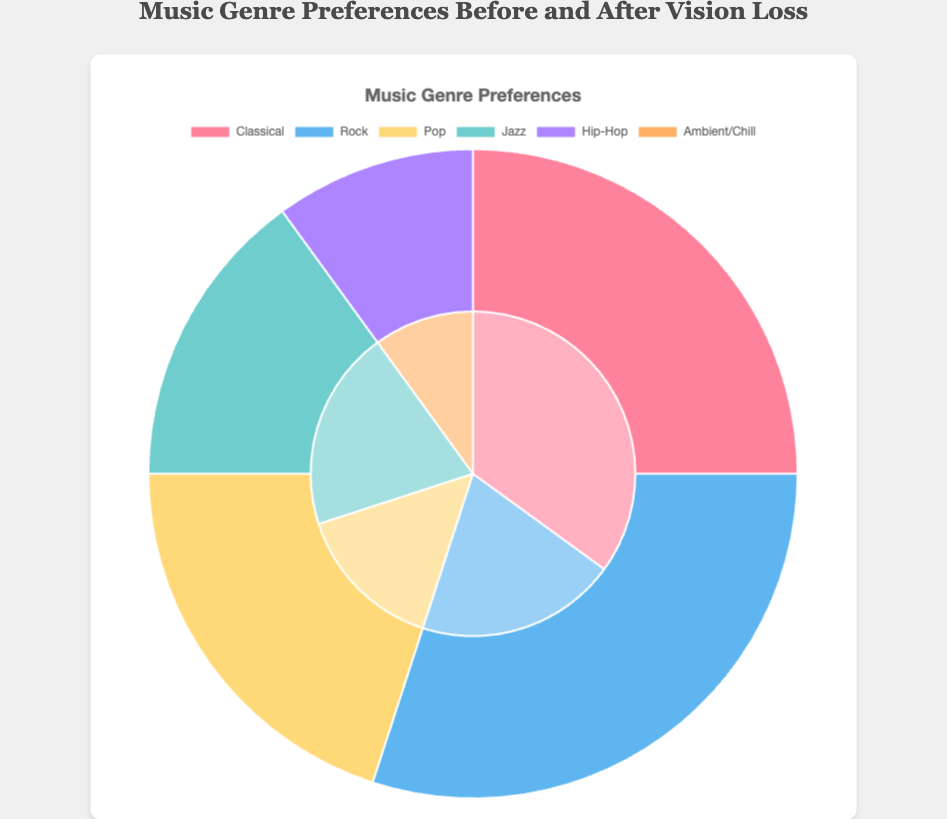Which genre saw the biggest increase after vision loss? Compare the percentages of each genre before and after vision loss. Classical music increased from 25% to 35%, which is the largest increase.
Answer: Classical What is the total percentage of Pop and Jazz after vision loss? Sum the percentages of Pop and Jazz after vision loss: 15% (Pop) + 20% (Jazz) = 35%.
Answer: 35% Which genre was present before vision loss but not after? Identify the genre listed before vision loss but missing after: Hip-Hop was present before (10%) and is not listed after.
Answer: Hip-Hop What are the two genres with the same percentage after vision loss? Identify genres with identical percentages after vision loss. Both Jazz and Classical have 20%.
Answer: Jazz and Rock How has the preference for Rock music changed after vision loss? Compare the percentage of Rock before (30%) and after vision loss (20%). The difference is 30% - 20% = 10%.
Answer: Decreased by 10% Which genre was added to the preferences after vision loss? Identify the genre present after vision loss but not before: Ambient/Chill makes its first appearance with 10%.
Answer: Ambient/Chill What is the combined percentage of Classical and Pop music before vision loss? Sum the percentages of Classical and Pop before vision loss: 25% (Classical) + 20% (Pop) = 45%.
Answer: 45% Which genre decreased and by what amount after vision loss? Rock music went from 30% to 20%, a decrease of 30% - 20% = 10%.
Answer: Rock, decreased by 10% What is the average percentage of all genres before vision loss? Sum all percentages before vision loss: 25% (Classical) + 30% (Rock) + 20% (Pop) + 15% (Jazz) + 10% (Hip-Hop) = 100%. Then divide by the number of genres: 100% / 5 = 20%.
Answer: 20% 